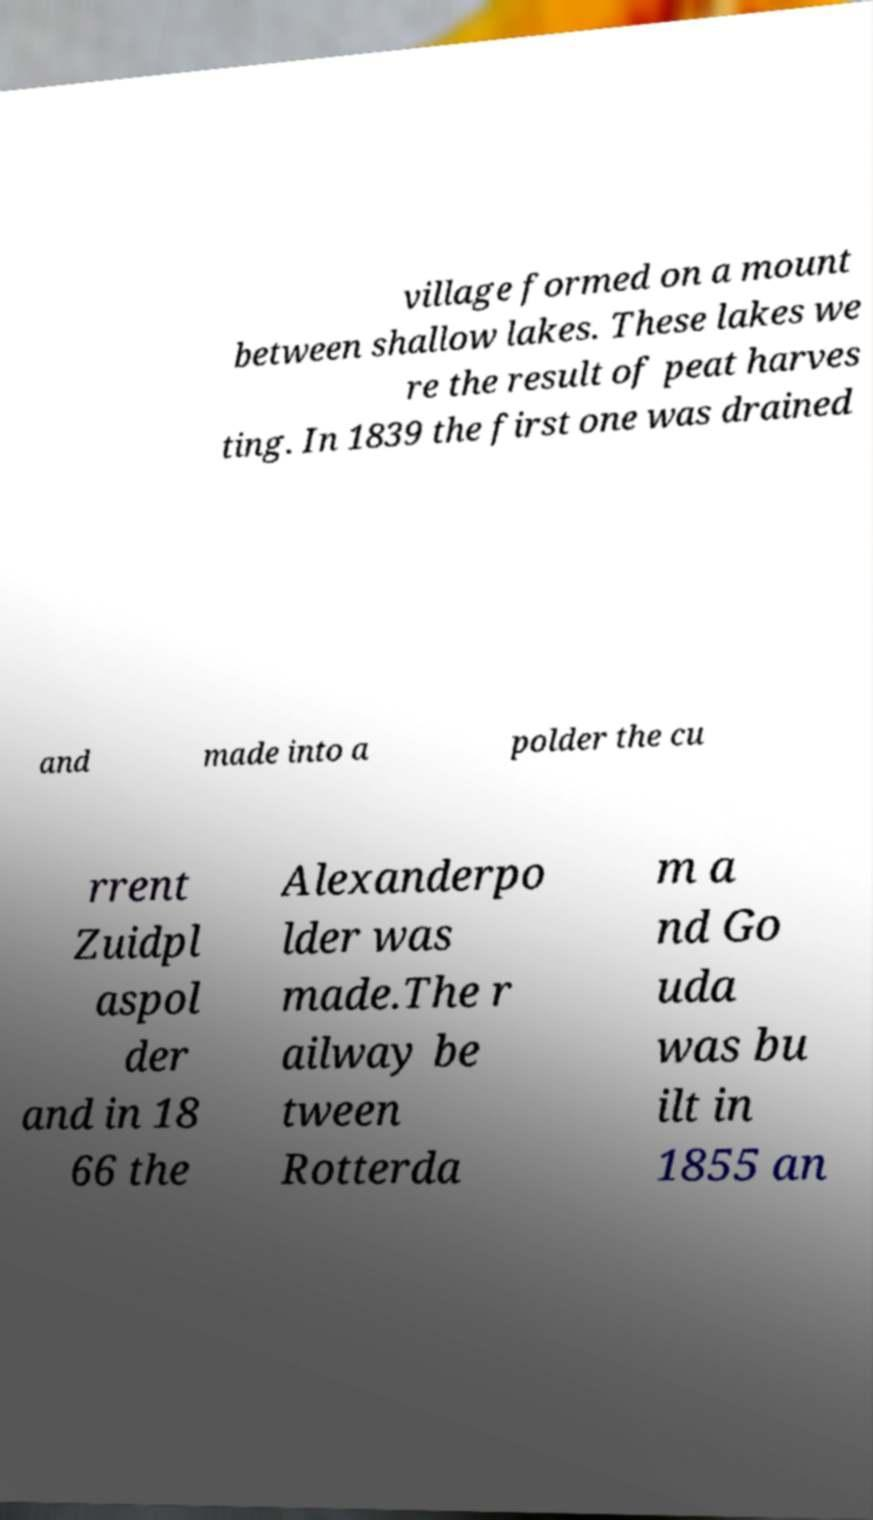There's text embedded in this image that I need extracted. Can you transcribe it verbatim? village formed on a mount between shallow lakes. These lakes we re the result of peat harves ting. In 1839 the first one was drained and made into a polder the cu rrent Zuidpl aspol der and in 18 66 the Alexanderpo lder was made.The r ailway be tween Rotterda m a nd Go uda was bu ilt in 1855 an 